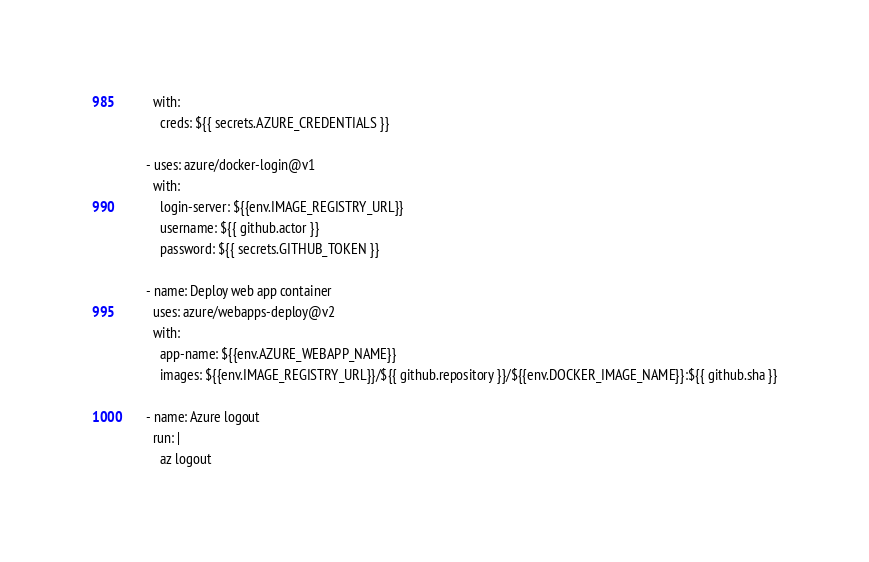<code> <loc_0><loc_0><loc_500><loc_500><_YAML_>        with:
          creds: ${{ secrets.AZURE_CREDENTIALS }}

      - uses: azure/docker-login@v1
        with:
          login-server: ${{env.IMAGE_REGISTRY_URL}}
          username: ${{ github.actor }}
          password: ${{ secrets.GITHUB_TOKEN }}

      - name: Deploy web app container
        uses: azure/webapps-deploy@v2
        with:
          app-name: ${{env.AZURE_WEBAPP_NAME}}
          images: ${{env.IMAGE_REGISTRY_URL}}/${{ github.repository }}/${{env.DOCKER_IMAGE_NAME}}:${{ github.sha }}

      - name: Azure logout
        run: |
          az logout
</code> 